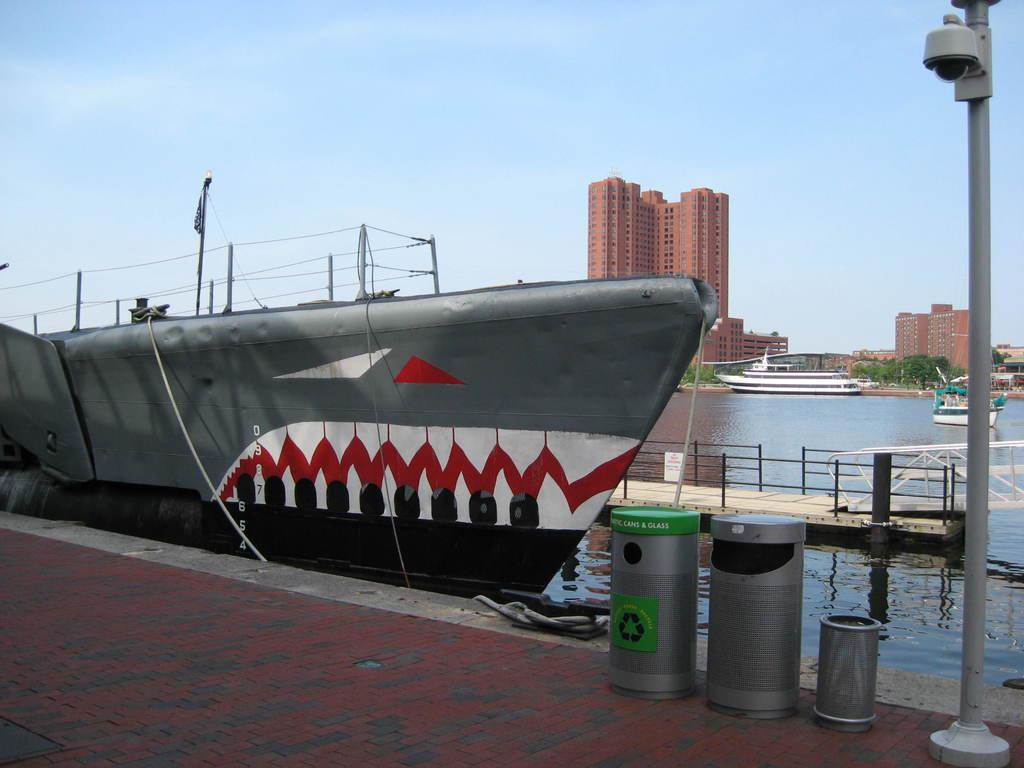<image>
Create a compact narrative representing the image presented. a shark boat next to a barrel that says recycle on it 